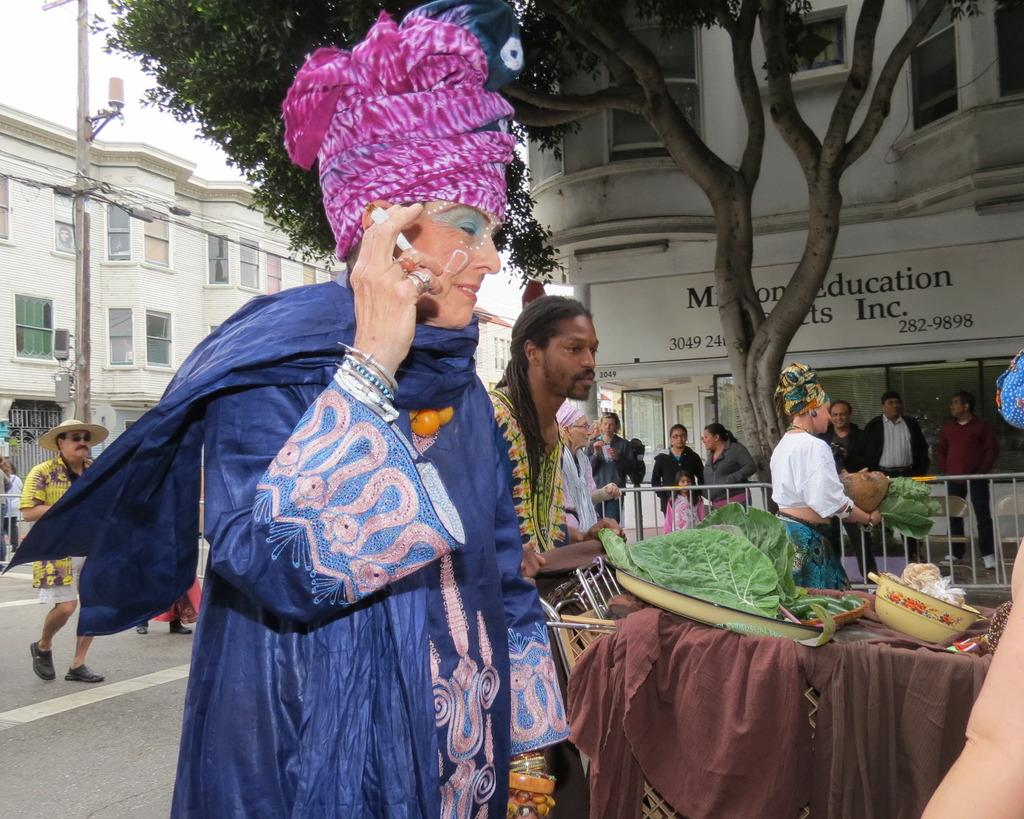How many people are in the image? There are persons in the image, but the exact number cannot be determined from the provided facts. What type of natural elements can be seen in the image? There are leaves and a tree in the image. What objects are present for serving food? There are plates and a bowl in the image. What type of material is present in the image? There is cloth in the image. What architectural feature can be seen in the image? There is a fence in the image. What type of man-made structure is visible in the image? There is a road in the image. What vertical structure can be seen in the image? There is a pole in the image. What type of structures are visible in the background of the image? There are buildings in the background of the image. What type of signage is visible in the background of the image? There is a board in the background of the image. What type of natural element is visible in the background of the image? There is a tree in the background of the image. What part of the natural environment is visible in the background of the image? There is sky visible in the background of the image. What is the rate of the ongoing discussion among the balls in the image? There are no balls present in the image, and therefore no discussion can be observed. 